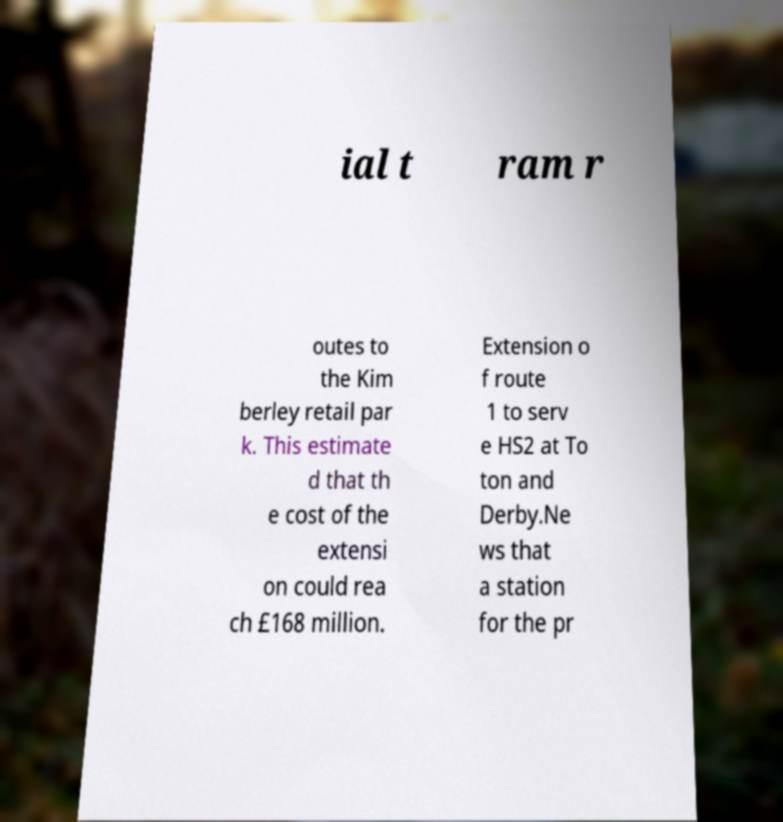Could you assist in decoding the text presented in this image and type it out clearly? ial t ram r outes to the Kim berley retail par k. This estimate d that th e cost of the extensi on could rea ch £168 million. Extension o f route 1 to serv e HS2 at To ton and Derby.Ne ws that a station for the pr 